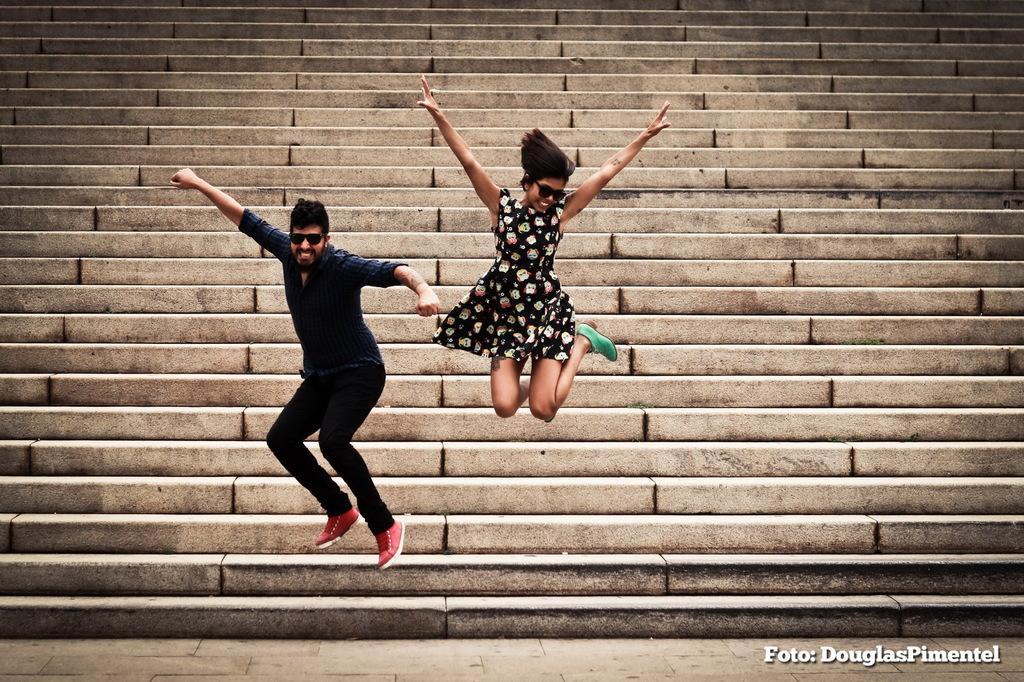Please provide a concise description of this image. In this picture there is a boy wearing black color shirt and jumping from the steps. Beside there is a girl wearing black top and green shoes is jumping and giving a pose. In the background there are many steps. 